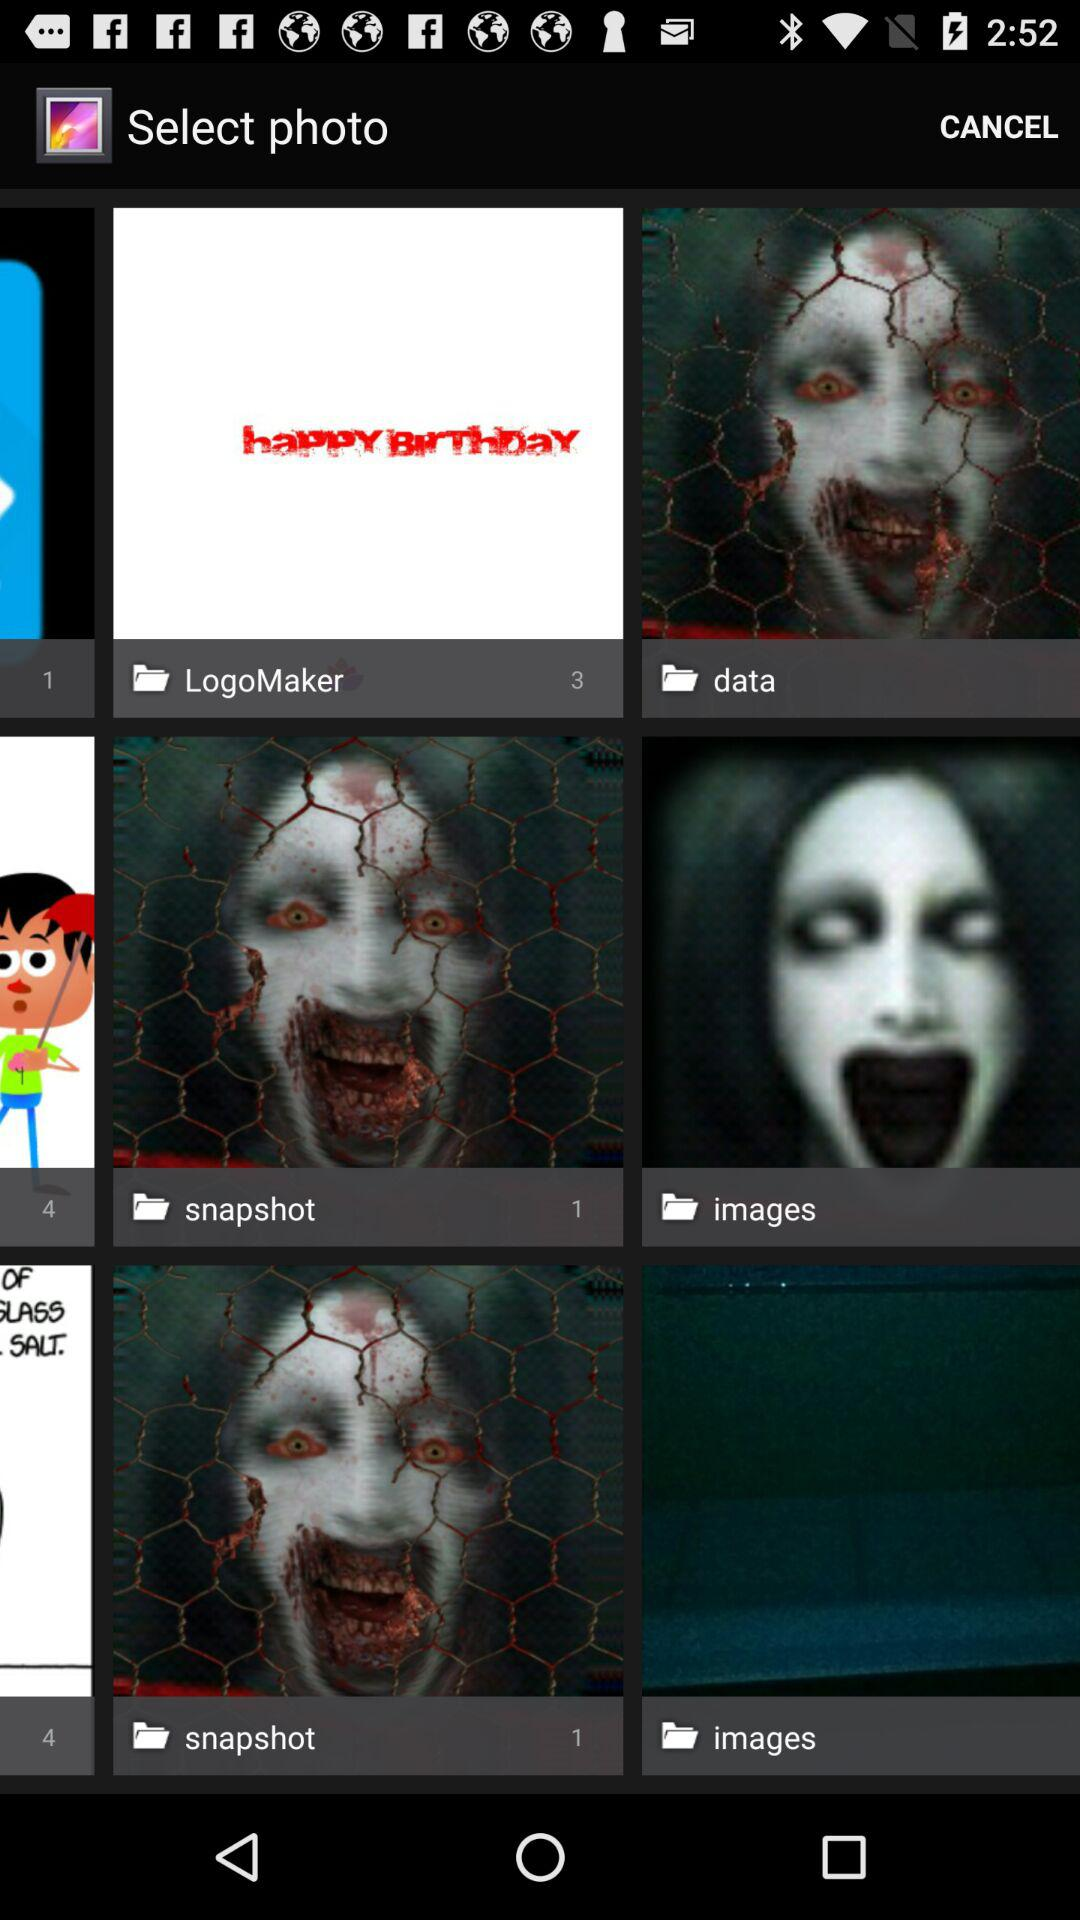How many photos in total are there in "LogoMaker"? There are total 3 photos. 